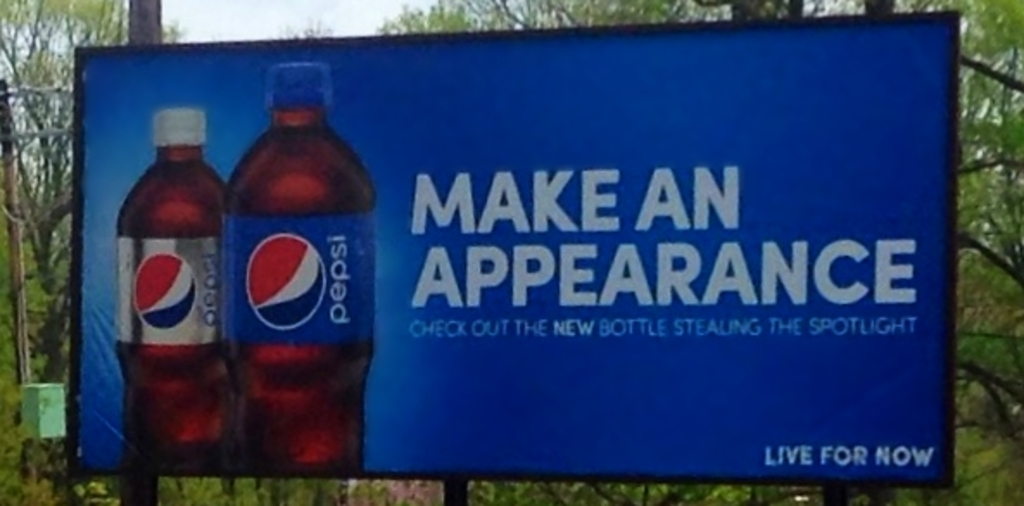What do you see happening in this image? The image showcases a billboard advertisement for Pepsi. The billboard is set against a backdrop of a blue sky with trees in the distance. The advertisement prominently features two bottles of Pepsi. One of the bottles is in the original design, while the other showcases a new design. The text on the billboard encourages viewers to "Make an appearance" and to "Check out the new bottle stealing the spotlight." The message concludes with Pepsi's tagline, "Live for now." 